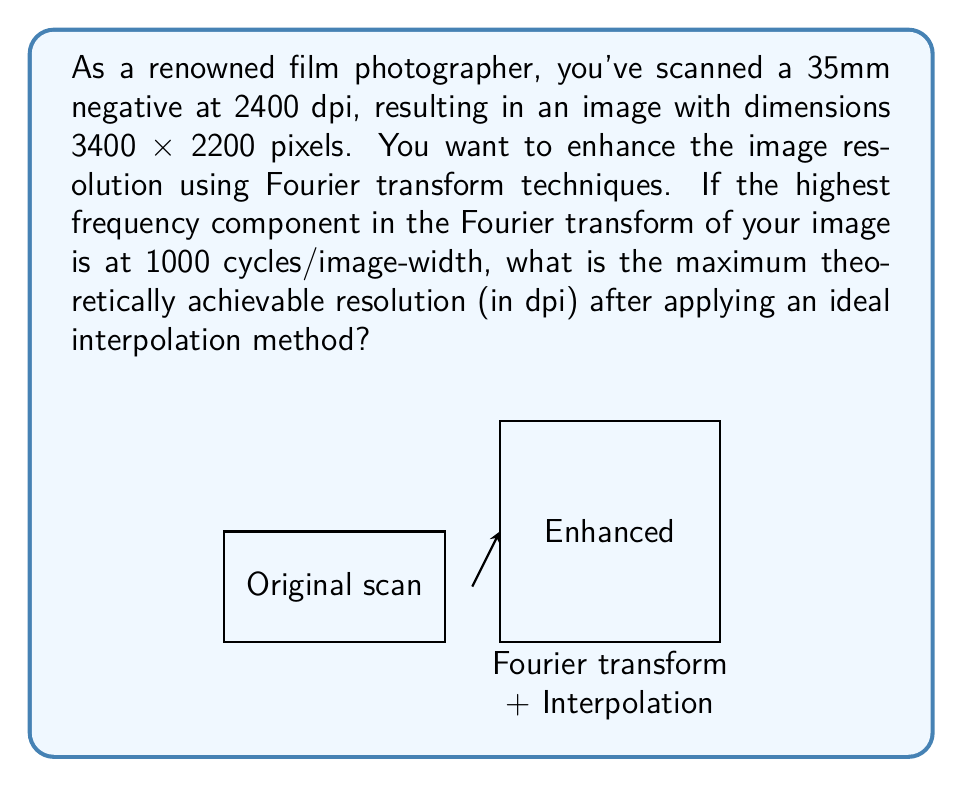What is the answer to this math problem? Let's approach this step-by-step:

1) First, we need to understand the Nyquist-Shannon sampling theorem. It states that to perfectly reconstruct a signal, the sampling rate must be at least twice the highest frequency component in the signal.

2) In our case, the highest frequency component is 1000 cycles/image-width. This means we need at least 2000 samples across the image width for perfect reconstruction.

3) The current image width is 3400 pixels. To find the maximum achievable width, we set up the proportion:

   $$\frac{3400 \text{ pixels}}{2400 \text{ dpi}} = \frac{2000 \text{ pixels}}{x \text{ dpi}}$$

4) Cross-multiplying:

   $$3400x = 2000 \cdot 2400$$

5) Solving for x:

   $$x = \frac{2000 \cdot 2400}{3400} \approx 1411.76 \text{ dpi}$$

6) This is the maximum theoretically achievable resolution after applying an ideal interpolation method based on the Fourier transform of the image.
Answer: 1412 dpi 